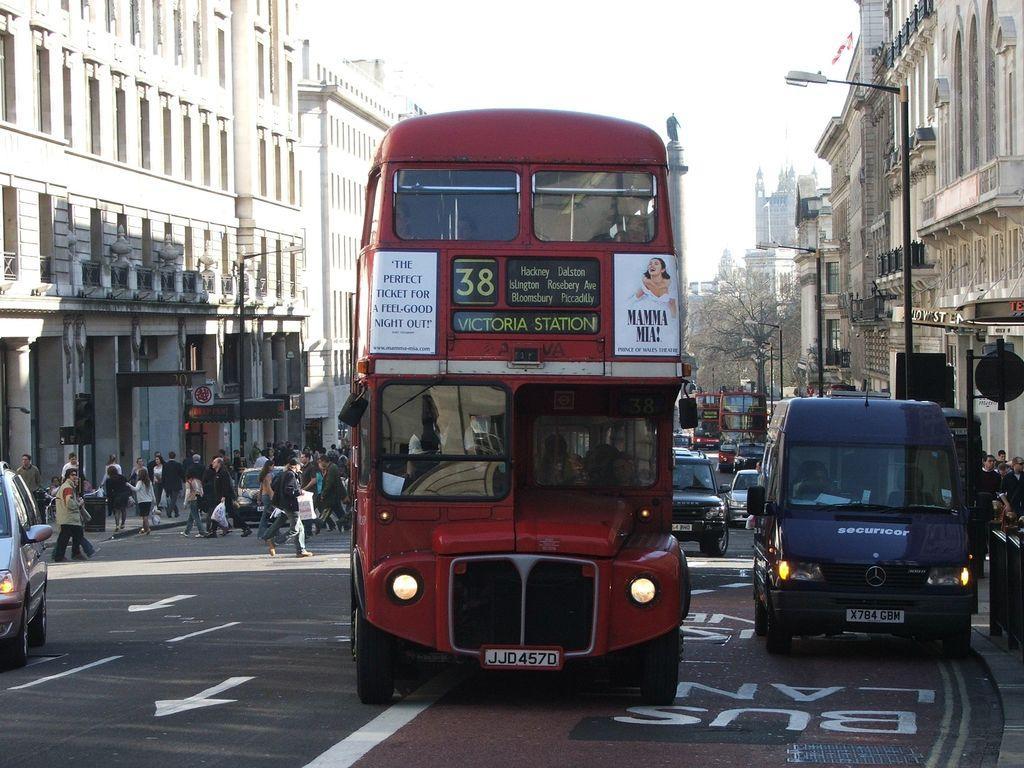Could you give a brief overview of what you see in this image? In this image, we can see people in the vehicles on the road. In the background, there are vehicles, people, buildings, walls, street lights, trees, pillars, boards and the sky. 